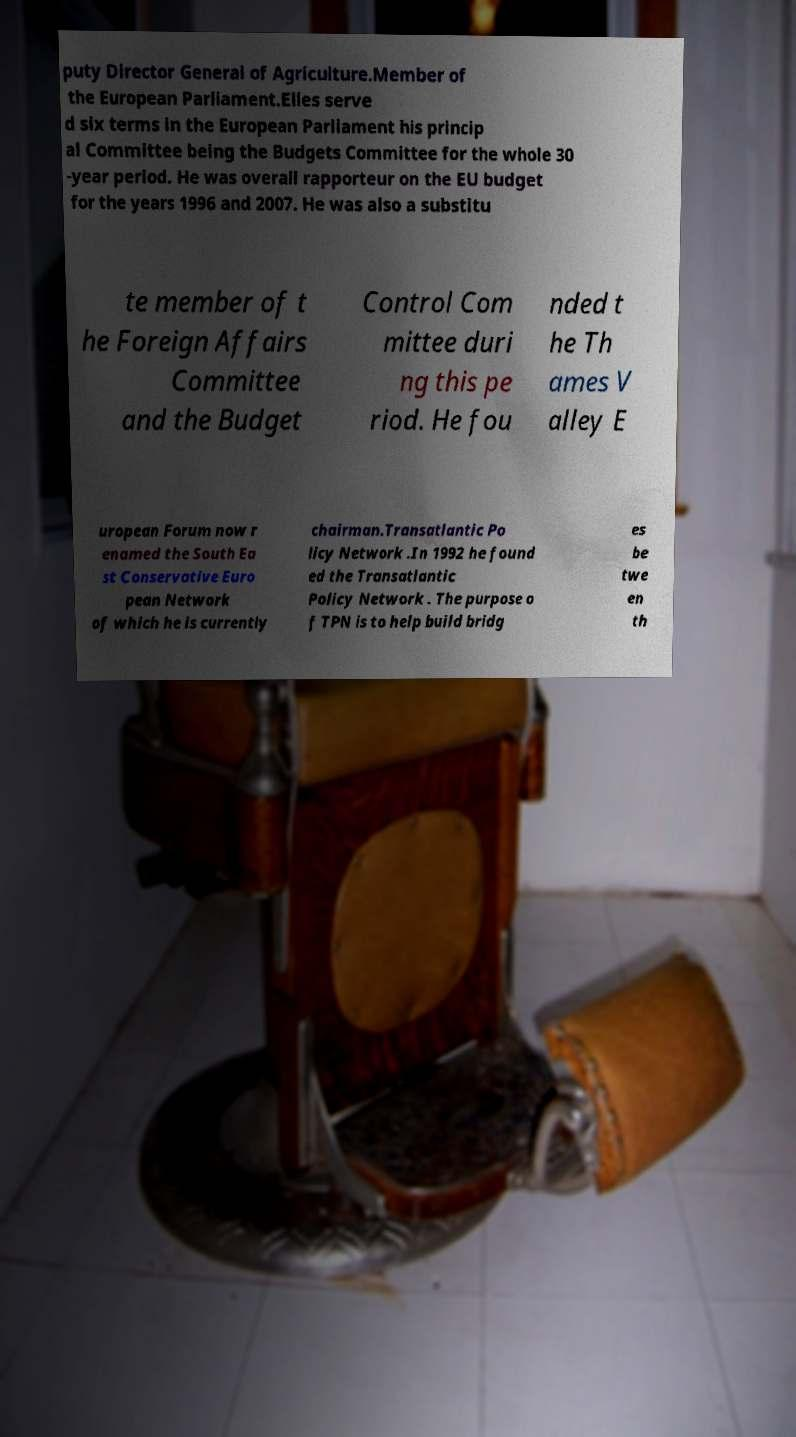Could you assist in decoding the text presented in this image and type it out clearly? puty Director General of Agriculture.Member of the European Parliament.Elles serve d six terms in the European Parliament his princip al Committee being the Budgets Committee for the whole 30 -year period. He was overall rapporteur on the EU budget for the years 1996 and 2007. He was also a substitu te member of t he Foreign Affairs Committee and the Budget Control Com mittee duri ng this pe riod. He fou nded t he Th ames V alley E uropean Forum now r enamed the South Ea st Conservative Euro pean Network of which he is currently chairman.Transatlantic Po licy Network .In 1992 he found ed the Transatlantic Policy Network . The purpose o f TPN is to help build bridg es be twe en th 